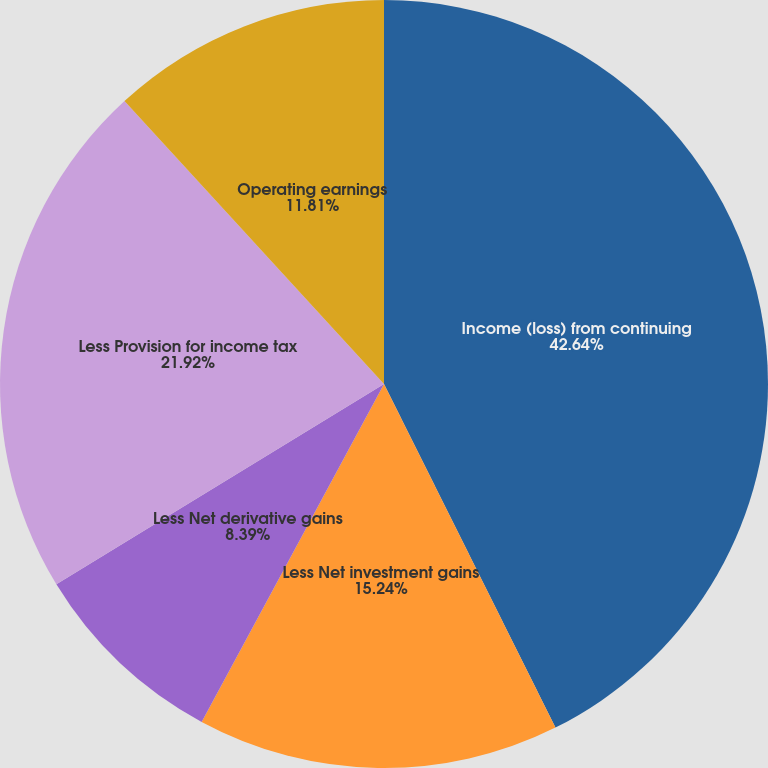<chart> <loc_0><loc_0><loc_500><loc_500><pie_chart><fcel>Income (loss) from continuing<fcel>Less Net investment gains<fcel>Less Net derivative gains<fcel>Less Provision for income tax<fcel>Operating earnings<nl><fcel>42.63%<fcel>15.24%<fcel>8.39%<fcel>21.92%<fcel>11.81%<nl></chart> 